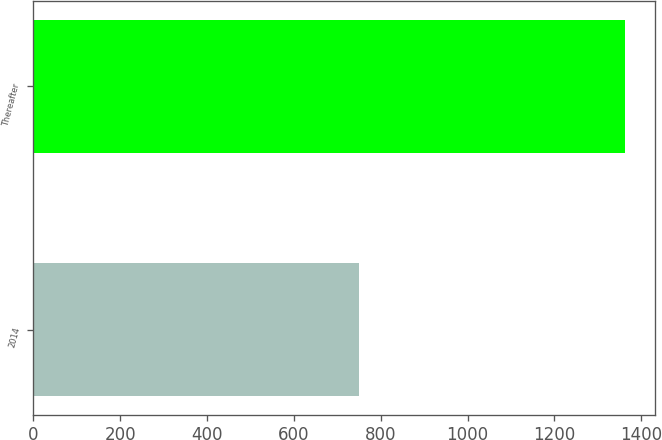Convert chart to OTSL. <chart><loc_0><loc_0><loc_500><loc_500><bar_chart><fcel>2014<fcel>Thereafter<nl><fcel>750<fcel>1362.5<nl></chart> 